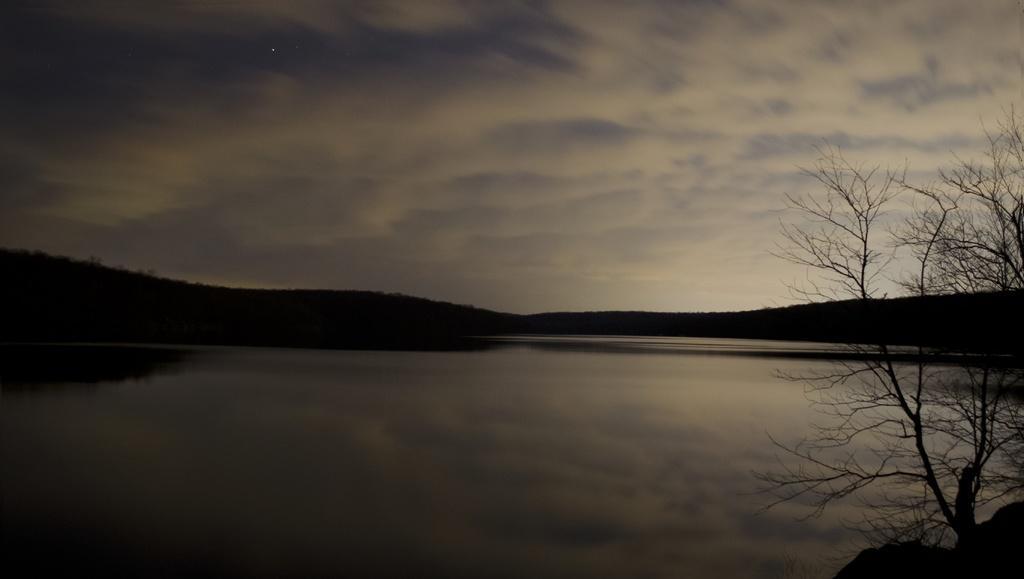Could you give a brief overview of what you see in this image? In this image we can see water and on the right side there is a bare tree. In the background the image is dark and it is not clear to describe but we can see clouds in the sky. 